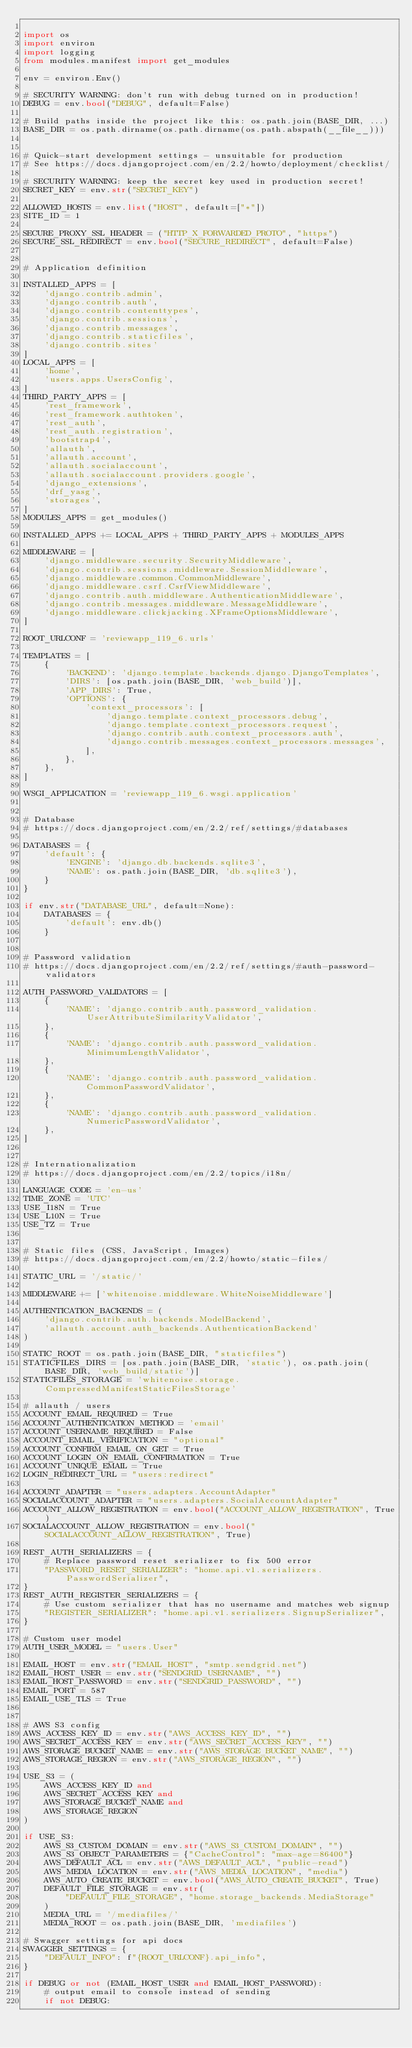<code> <loc_0><loc_0><loc_500><loc_500><_Python_>
import os
import environ
import logging
from modules.manifest import get_modules

env = environ.Env()

# SECURITY WARNING: don't run with debug turned on in production!
DEBUG = env.bool("DEBUG", default=False)

# Build paths inside the project like this: os.path.join(BASE_DIR, ...)
BASE_DIR = os.path.dirname(os.path.dirname(os.path.abspath(__file__)))


# Quick-start development settings - unsuitable for production
# See https://docs.djangoproject.com/en/2.2/howto/deployment/checklist/

# SECURITY WARNING: keep the secret key used in production secret!
SECRET_KEY = env.str("SECRET_KEY")

ALLOWED_HOSTS = env.list("HOST", default=["*"])
SITE_ID = 1

SECURE_PROXY_SSL_HEADER = ("HTTP_X_FORWARDED_PROTO", "https")
SECURE_SSL_REDIRECT = env.bool("SECURE_REDIRECT", default=False)


# Application definition

INSTALLED_APPS = [
    'django.contrib.admin',
    'django.contrib.auth',
    'django.contrib.contenttypes',
    'django.contrib.sessions',
    'django.contrib.messages',
    'django.contrib.staticfiles',
    'django.contrib.sites'
]
LOCAL_APPS = [
    'home',
    'users.apps.UsersConfig',
]
THIRD_PARTY_APPS = [
    'rest_framework',
    'rest_framework.authtoken',
    'rest_auth',
    'rest_auth.registration',
    'bootstrap4',
    'allauth',
    'allauth.account',
    'allauth.socialaccount',
    'allauth.socialaccount.providers.google',
    'django_extensions',
    'drf_yasg',
    'storages',
]
MODULES_APPS = get_modules()

INSTALLED_APPS += LOCAL_APPS + THIRD_PARTY_APPS + MODULES_APPS

MIDDLEWARE = [
    'django.middleware.security.SecurityMiddleware',
    'django.contrib.sessions.middleware.SessionMiddleware',
    'django.middleware.common.CommonMiddleware',
    'django.middleware.csrf.CsrfViewMiddleware',
    'django.contrib.auth.middleware.AuthenticationMiddleware',
    'django.contrib.messages.middleware.MessageMiddleware',
    'django.middleware.clickjacking.XFrameOptionsMiddleware',
]

ROOT_URLCONF = 'reviewapp_119_6.urls'

TEMPLATES = [
    {
        'BACKEND': 'django.template.backends.django.DjangoTemplates',
        'DIRS': [os.path.join(BASE_DIR, 'web_build')],
        'APP_DIRS': True,
        'OPTIONS': {
            'context_processors': [
                'django.template.context_processors.debug',
                'django.template.context_processors.request',
                'django.contrib.auth.context_processors.auth',
                'django.contrib.messages.context_processors.messages',
            ],
        },
    },
]

WSGI_APPLICATION = 'reviewapp_119_6.wsgi.application'


# Database
# https://docs.djangoproject.com/en/2.2/ref/settings/#databases

DATABASES = {
    'default': {
        'ENGINE': 'django.db.backends.sqlite3',
        'NAME': os.path.join(BASE_DIR, 'db.sqlite3'),
    }
}

if env.str("DATABASE_URL", default=None):
    DATABASES = {
        'default': env.db()
    }


# Password validation
# https://docs.djangoproject.com/en/2.2/ref/settings/#auth-password-validators

AUTH_PASSWORD_VALIDATORS = [
    {
        'NAME': 'django.contrib.auth.password_validation.UserAttributeSimilarityValidator',
    },
    {
        'NAME': 'django.contrib.auth.password_validation.MinimumLengthValidator',
    },
    {
        'NAME': 'django.contrib.auth.password_validation.CommonPasswordValidator',
    },
    {
        'NAME': 'django.contrib.auth.password_validation.NumericPasswordValidator',
    },
]


# Internationalization
# https://docs.djangoproject.com/en/2.2/topics/i18n/

LANGUAGE_CODE = 'en-us'
TIME_ZONE = 'UTC'
USE_I18N = True
USE_L10N = True
USE_TZ = True


# Static files (CSS, JavaScript, Images)
# https://docs.djangoproject.com/en/2.2/howto/static-files/

STATIC_URL = '/static/'

MIDDLEWARE += ['whitenoise.middleware.WhiteNoiseMiddleware']

AUTHENTICATION_BACKENDS = (
    'django.contrib.auth.backends.ModelBackend',
    'allauth.account.auth_backends.AuthenticationBackend'
)

STATIC_ROOT = os.path.join(BASE_DIR, "staticfiles")
STATICFILES_DIRS = [os.path.join(BASE_DIR, 'static'), os.path.join(BASE_DIR, 'web_build/static')]
STATICFILES_STORAGE = 'whitenoise.storage.CompressedManifestStaticFilesStorage'

# allauth / users
ACCOUNT_EMAIL_REQUIRED = True
ACCOUNT_AUTHENTICATION_METHOD = 'email'
ACCOUNT_USERNAME_REQUIRED = False
ACCOUNT_EMAIL_VERIFICATION = "optional"
ACCOUNT_CONFIRM_EMAIL_ON_GET = True
ACCOUNT_LOGIN_ON_EMAIL_CONFIRMATION = True
ACCOUNT_UNIQUE_EMAIL = True
LOGIN_REDIRECT_URL = "users:redirect"

ACCOUNT_ADAPTER = "users.adapters.AccountAdapter"
SOCIALACCOUNT_ADAPTER = "users.adapters.SocialAccountAdapter"
ACCOUNT_ALLOW_REGISTRATION = env.bool("ACCOUNT_ALLOW_REGISTRATION", True)
SOCIALACCOUNT_ALLOW_REGISTRATION = env.bool("SOCIALACCOUNT_ALLOW_REGISTRATION", True)

REST_AUTH_SERIALIZERS = {
    # Replace password reset serializer to fix 500 error
    "PASSWORD_RESET_SERIALIZER": "home.api.v1.serializers.PasswordSerializer",
}
REST_AUTH_REGISTER_SERIALIZERS = {
    # Use custom serializer that has no username and matches web signup
    "REGISTER_SERIALIZER": "home.api.v1.serializers.SignupSerializer",
}

# Custom user model
AUTH_USER_MODEL = "users.User"

EMAIL_HOST = env.str("EMAIL_HOST", "smtp.sendgrid.net")
EMAIL_HOST_USER = env.str("SENDGRID_USERNAME", "")
EMAIL_HOST_PASSWORD = env.str("SENDGRID_PASSWORD", "")
EMAIL_PORT = 587
EMAIL_USE_TLS = True


# AWS S3 config
AWS_ACCESS_KEY_ID = env.str("AWS_ACCESS_KEY_ID", "")
AWS_SECRET_ACCESS_KEY = env.str("AWS_SECRET_ACCESS_KEY", "")
AWS_STORAGE_BUCKET_NAME = env.str("AWS_STORAGE_BUCKET_NAME", "")
AWS_STORAGE_REGION = env.str("AWS_STORAGE_REGION", "")

USE_S3 = (
    AWS_ACCESS_KEY_ID and
    AWS_SECRET_ACCESS_KEY and
    AWS_STORAGE_BUCKET_NAME and
    AWS_STORAGE_REGION
)

if USE_S3:
    AWS_S3_CUSTOM_DOMAIN = env.str("AWS_S3_CUSTOM_DOMAIN", "")
    AWS_S3_OBJECT_PARAMETERS = {"CacheControl": "max-age=86400"}
    AWS_DEFAULT_ACL = env.str("AWS_DEFAULT_ACL", "public-read")
    AWS_MEDIA_LOCATION = env.str("AWS_MEDIA_LOCATION", "media")
    AWS_AUTO_CREATE_BUCKET = env.bool("AWS_AUTO_CREATE_BUCKET", True)
    DEFAULT_FILE_STORAGE = env.str(
        "DEFAULT_FILE_STORAGE", "home.storage_backends.MediaStorage"
    )
    MEDIA_URL = '/mediafiles/'
    MEDIA_ROOT = os.path.join(BASE_DIR, 'mediafiles')

# Swagger settings for api docs
SWAGGER_SETTINGS = {
    "DEFAULT_INFO": f"{ROOT_URLCONF}.api_info",
}

if DEBUG or not (EMAIL_HOST_USER and EMAIL_HOST_PASSWORD):
    # output email to console instead of sending
    if not DEBUG:</code> 